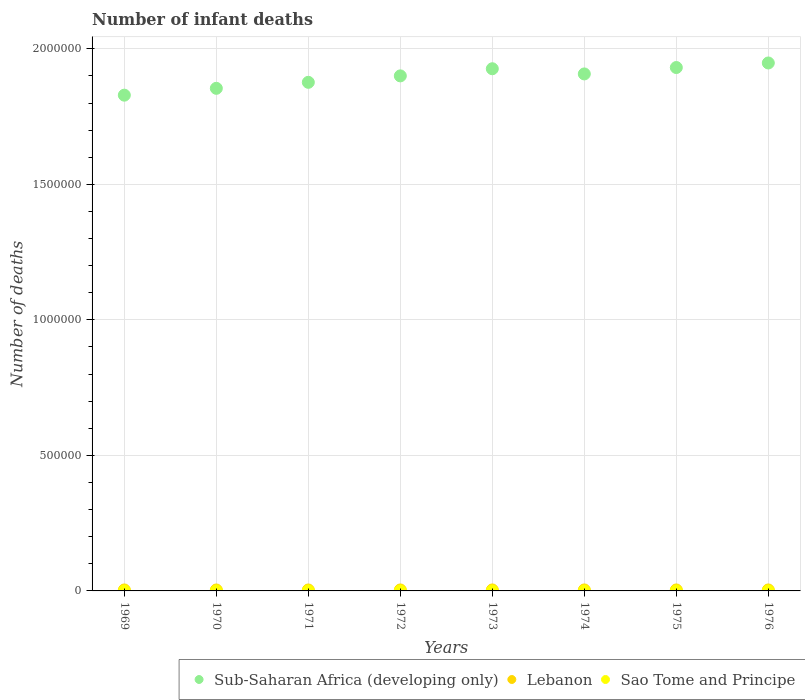What is the number of infant deaths in Lebanon in 1976?
Give a very brief answer. 3581. Across all years, what is the maximum number of infant deaths in Lebanon?
Give a very brief answer. 3623. Across all years, what is the minimum number of infant deaths in Sub-Saharan Africa (developing only)?
Keep it short and to the point. 1.83e+06. In which year was the number of infant deaths in Sao Tome and Principe maximum?
Your answer should be very brief. 1976. In which year was the number of infant deaths in Sub-Saharan Africa (developing only) minimum?
Your response must be concise. 1969. What is the total number of infant deaths in Lebanon in the graph?
Your response must be concise. 2.84e+04. What is the difference between the number of infant deaths in Lebanon in 1972 and that in 1973?
Provide a succinct answer. -52. What is the difference between the number of infant deaths in Sao Tome and Principe in 1971 and the number of infant deaths in Lebanon in 1970?
Ensure brevity in your answer.  -3272. What is the average number of infant deaths in Sao Tome and Principe per year?
Offer a very short reply. 214.12. In the year 1976, what is the difference between the number of infant deaths in Sub-Saharan Africa (developing only) and number of infant deaths in Lebanon?
Keep it short and to the point. 1.94e+06. What is the ratio of the number of infant deaths in Sub-Saharan Africa (developing only) in 1970 to that in 1972?
Ensure brevity in your answer.  0.98. Is the number of infant deaths in Lebanon in 1969 less than that in 1975?
Your answer should be compact. Yes. Is the difference between the number of infant deaths in Sub-Saharan Africa (developing only) in 1974 and 1975 greater than the difference between the number of infant deaths in Lebanon in 1974 and 1975?
Give a very brief answer. No. What is the difference between the highest and the second highest number of infant deaths in Sub-Saharan Africa (developing only)?
Give a very brief answer. 1.68e+04. In how many years, is the number of infant deaths in Lebanon greater than the average number of infant deaths in Lebanon taken over all years?
Ensure brevity in your answer.  4. Is the sum of the number of infant deaths in Lebanon in 1969 and 1974 greater than the maximum number of infant deaths in Sub-Saharan Africa (developing only) across all years?
Offer a terse response. No. Is the number of infant deaths in Sub-Saharan Africa (developing only) strictly less than the number of infant deaths in Sao Tome and Principe over the years?
Your answer should be very brief. No. What is the difference between two consecutive major ticks on the Y-axis?
Provide a short and direct response. 5.00e+05. Does the graph contain any zero values?
Ensure brevity in your answer.  No. Does the graph contain grids?
Ensure brevity in your answer.  Yes. How are the legend labels stacked?
Give a very brief answer. Horizontal. What is the title of the graph?
Ensure brevity in your answer.  Number of infant deaths. What is the label or title of the Y-axis?
Your response must be concise. Number of deaths. What is the Number of deaths of Sub-Saharan Africa (developing only) in 1969?
Provide a short and direct response. 1.83e+06. What is the Number of deaths of Lebanon in 1969?
Offer a terse response. 3530. What is the Number of deaths of Sao Tome and Principe in 1969?
Offer a very short reply. 204. What is the Number of deaths of Sub-Saharan Africa (developing only) in 1970?
Keep it short and to the point. 1.85e+06. What is the Number of deaths in Lebanon in 1970?
Provide a succinct answer. 3483. What is the Number of deaths in Sao Tome and Principe in 1970?
Your response must be concise. 209. What is the Number of deaths in Sub-Saharan Africa (developing only) in 1971?
Keep it short and to the point. 1.88e+06. What is the Number of deaths in Lebanon in 1971?
Offer a very short reply. 3481. What is the Number of deaths of Sao Tome and Principe in 1971?
Keep it short and to the point. 211. What is the Number of deaths in Sub-Saharan Africa (developing only) in 1972?
Keep it short and to the point. 1.90e+06. What is the Number of deaths of Lebanon in 1972?
Keep it short and to the point. 3532. What is the Number of deaths in Sao Tome and Principe in 1972?
Make the answer very short. 211. What is the Number of deaths in Sub-Saharan Africa (developing only) in 1973?
Give a very brief answer. 1.93e+06. What is the Number of deaths in Lebanon in 1973?
Your answer should be very brief. 3584. What is the Number of deaths of Sao Tome and Principe in 1973?
Offer a terse response. 211. What is the Number of deaths of Sub-Saharan Africa (developing only) in 1974?
Your answer should be compact. 1.91e+06. What is the Number of deaths of Lebanon in 1974?
Your answer should be very brief. 3623. What is the Number of deaths in Sao Tome and Principe in 1974?
Your answer should be compact. 213. What is the Number of deaths in Sub-Saharan Africa (developing only) in 1975?
Offer a terse response. 1.93e+06. What is the Number of deaths of Lebanon in 1975?
Ensure brevity in your answer.  3601. What is the Number of deaths in Sao Tome and Principe in 1975?
Your answer should be compact. 221. What is the Number of deaths in Sub-Saharan Africa (developing only) in 1976?
Provide a short and direct response. 1.95e+06. What is the Number of deaths of Lebanon in 1976?
Provide a succinct answer. 3581. What is the Number of deaths of Sao Tome and Principe in 1976?
Provide a short and direct response. 233. Across all years, what is the maximum Number of deaths in Sub-Saharan Africa (developing only)?
Your response must be concise. 1.95e+06. Across all years, what is the maximum Number of deaths of Lebanon?
Your answer should be compact. 3623. Across all years, what is the maximum Number of deaths in Sao Tome and Principe?
Keep it short and to the point. 233. Across all years, what is the minimum Number of deaths of Sub-Saharan Africa (developing only)?
Your answer should be very brief. 1.83e+06. Across all years, what is the minimum Number of deaths of Lebanon?
Ensure brevity in your answer.  3481. Across all years, what is the minimum Number of deaths of Sao Tome and Principe?
Make the answer very short. 204. What is the total Number of deaths of Sub-Saharan Africa (developing only) in the graph?
Ensure brevity in your answer.  1.52e+07. What is the total Number of deaths in Lebanon in the graph?
Your answer should be compact. 2.84e+04. What is the total Number of deaths of Sao Tome and Principe in the graph?
Give a very brief answer. 1713. What is the difference between the Number of deaths in Sub-Saharan Africa (developing only) in 1969 and that in 1970?
Ensure brevity in your answer.  -2.52e+04. What is the difference between the Number of deaths of Lebanon in 1969 and that in 1970?
Provide a succinct answer. 47. What is the difference between the Number of deaths in Sao Tome and Principe in 1969 and that in 1970?
Your response must be concise. -5. What is the difference between the Number of deaths in Sub-Saharan Africa (developing only) in 1969 and that in 1971?
Provide a short and direct response. -4.74e+04. What is the difference between the Number of deaths of Sub-Saharan Africa (developing only) in 1969 and that in 1972?
Offer a very short reply. -7.11e+04. What is the difference between the Number of deaths of Sao Tome and Principe in 1969 and that in 1972?
Your answer should be very brief. -7. What is the difference between the Number of deaths in Sub-Saharan Africa (developing only) in 1969 and that in 1973?
Keep it short and to the point. -9.75e+04. What is the difference between the Number of deaths of Lebanon in 1969 and that in 1973?
Provide a succinct answer. -54. What is the difference between the Number of deaths in Sub-Saharan Africa (developing only) in 1969 and that in 1974?
Your answer should be very brief. -7.83e+04. What is the difference between the Number of deaths of Lebanon in 1969 and that in 1974?
Keep it short and to the point. -93. What is the difference between the Number of deaths in Sub-Saharan Africa (developing only) in 1969 and that in 1975?
Give a very brief answer. -1.02e+05. What is the difference between the Number of deaths of Lebanon in 1969 and that in 1975?
Provide a succinct answer. -71. What is the difference between the Number of deaths of Sub-Saharan Africa (developing only) in 1969 and that in 1976?
Your answer should be very brief. -1.19e+05. What is the difference between the Number of deaths of Lebanon in 1969 and that in 1976?
Give a very brief answer. -51. What is the difference between the Number of deaths of Sao Tome and Principe in 1969 and that in 1976?
Your answer should be very brief. -29. What is the difference between the Number of deaths in Sub-Saharan Africa (developing only) in 1970 and that in 1971?
Keep it short and to the point. -2.22e+04. What is the difference between the Number of deaths in Sao Tome and Principe in 1970 and that in 1971?
Offer a very short reply. -2. What is the difference between the Number of deaths of Sub-Saharan Africa (developing only) in 1970 and that in 1972?
Make the answer very short. -4.59e+04. What is the difference between the Number of deaths of Lebanon in 1970 and that in 1972?
Your answer should be compact. -49. What is the difference between the Number of deaths of Sao Tome and Principe in 1970 and that in 1972?
Give a very brief answer. -2. What is the difference between the Number of deaths of Sub-Saharan Africa (developing only) in 1970 and that in 1973?
Make the answer very short. -7.22e+04. What is the difference between the Number of deaths of Lebanon in 1970 and that in 1973?
Offer a terse response. -101. What is the difference between the Number of deaths of Sub-Saharan Africa (developing only) in 1970 and that in 1974?
Provide a short and direct response. -5.31e+04. What is the difference between the Number of deaths in Lebanon in 1970 and that in 1974?
Ensure brevity in your answer.  -140. What is the difference between the Number of deaths in Sao Tome and Principe in 1970 and that in 1974?
Your answer should be very brief. -4. What is the difference between the Number of deaths of Sub-Saharan Africa (developing only) in 1970 and that in 1975?
Ensure brevity in your answer.  -7.67e+04. What is the difference between the Number of deaths of Lebanon in 1970 and that in 1975?
Make the answer very short. -118. What is the difference between the Number of deaths in Sao Tome and Principe in 1970 and that in 1975?
Keep it short and to the point. -12. What is the difference between the Number of deaths in Sub-Saharan Africa (developing only) in 1970 and that in 1976?
Provide a short and direct response. -9.36e+04. What is the difference between the Number of deaths in Lebanon in 1970 and that in 1976?
Ensure brevity in your answer.  -98. What is the difference between the Number of deaths of Sao Tome and Principe in 1970 and that in 1976?
Give a very brief answer. -24. What is the difference between the Number of deaths of Sub-Saharan Africa (developing only) in 1971 and that in 1972?
Keep it short and to the point. -2.38e+04. What is the difference between the Number of deaths in Lebanon in 1971 and that in 1972?
Offer a very short reply. -51. What is the difference between the Number of deaths of Sub-Saharan Africa (developing only) in 1971 and that in 1973?
Ensure brevity in your answer.  -5.01e+04. What is the difference between the Number of deaths of Lebanon in 1971 and that in 1973?
Your answer should be very brief. -103. What is the difference between the Number of deaths of Sao Tome and Principe in 1971 and that in 1973?
Your answer should be compact. 0. What is the difference between the Number of deaths in Sub-Saharan Africa (developing only) in 1971 and that in 1974?
Provide a short and direct response. -3.10e+04. What is the difference between the Number of deaths of Lebanon in 1971 and that in 1974?
Your answer should be compact. -142. What is the difference between the Number of deaths of Sao Tome and Principe in 1971 and that in 1974?
Ensure brevity in your answer.  -2. What is the difference between the Number of deaths of Sub-Saharan Africa (developing only) in 1971 and that in 1975?
Offer a very short reply. -5.46e+04. What is the difference between the Number of deaths in Lebanon in 1971 and that in 1975?
Your answer should be compact. -120. What is the difference between the Number of deaths in Sao Tome and Principe in 1971 and that in 1975?
Offer a very short reply. -10. What is the difference between the Number of deaths of Sub-Saharan Africa (developing only) in 1971 and that in 1976?
Your answer should be compact. -7.14e+04. What is the difference between the Number of deaths in Lebanon in 1971 and that in 1976?
Offer a very short reply. -100. What is the difference between the Number of deaths in Sao Tome and Principe in 1971 and that in 1976?
Your answer should be compact. -22. What is the difference between the Number of deaths of Sub-Saharan Africa (developing only) in 1972 and that in 1973?
Ensure brevity in your answer.  -2.63e+04. What is the difference between the Number of deaths in Lebanon in 1972 and that in 1973?
Provide a short and direct response. -52. What is the difference between the Number of deaths of Sub-Saharan Africa (developing only) in 1972 and that in 1974?
Provide a succinct answer. -7205. What is the difference between the Number of deaths in Lebanon in 1972 and that in 1974?
Make the answer very short. -91. What is the difference between the Number of deaths of Sao Tome and Principe in 1972 and that in 1974?
Ensure brevity in your answer.  -2. What is the difference between the Number of deaths of Sub-Saharan Africa (developing only) in 1972 and that in 1975?
Your answer should be very brief. -3.08e+04. What is the difference between the Number of deaths in Lebanon in 1972 and that in 1975?
Provide a succinct answer. -69. What is the difference between the Number of deaths in Sao Tome and Principe in 1972 and that in 1975?
Offer a terse response. -10. What is the difference between the Number of deaths of Sub-Saharan Africa (developing only) in 1972 and that in 1976?
Provide a short and direct response. -4.76e+04. What is the difference between the Number of deaths in Lebanon in 1972 and that in 1976?
Your answer should be compact. -49. What is the difference between the Number of deaths in Sub-Saharan Africa (developing only) in 1973 and that in 1974?
Offer a very short reply. 1.91e+04. What is the difference between the Number of deaths of Lebanon in 1973 and that in 1974?
Provide a succinct answer. -39. What is the difference between the Number of deaths of Sao Tome and Principe in 1973 and that in 1974?
Offer a terse response. -2. What is the difference between the Number of deaths in Sub-Saharan Africa (developing only) in 1973 and that in 1975?
Your response must be concise. -4511. What is the difference between the Number of deaths of Sub-Saharan Africa (developing only) in 1973 and that in 1976?
Provide a short and direct response. -2.13e+04. What is the difference between the Number of deaths of Lebanon in 1973 and that in 1976?
Offer a terse response. 3. What is the difference between the Number of deaths of Sao Tome and Principe in 1973 and that in 1976?
Your answer should be very brief. -22. What is the difference between the Number of deaths in Sub-Saharan Africa (developing only) in 1974 and that in 1975?
Offer a terse response. -2.36e+04. What is the difference between the Number of deaths in Lebanon in 1974 and that in 1975?
Your answer should be compact. 22. What is the difference between the Number of deaths in Sub-Saharan Africa (developing only) in 1974 and that in 1976?
Ensure brevity in your answer.  -4.04e+04. What is the difference between the Number of deaths in Sub-Saharan Africa (developing only) in 1975 and that in 1976?
Offer a terse response. -1.68e+04. What is the difference between the Number of deaths of Sao Tome and Principe in 1975 and that in 1976?
Provide a short and direct response. -12. What is the difference between the Number of deaths in Sub-Saharan Africa (developing only) in 1969 and the Number of deaths in Lebanon in 1970?
Your answer should be compact. 1.83e+06. What is the difference between the Number of deaths in Sub-Saharan Africa (developing only) in 1969 and the Number of deaths in Sao Tome and Principe in 1970?
Offer a very short reply. 1.83e+06. What is the difference between the Number of deaths of Lebanon in 1969 and the Number of deaths of Sao Tome and Principe in 1970?
Offer a very short reply. 3321. What is the difference between the Number of deaths of Sub-Saharan Africa (developing only) in 1969 and the Number of deaths of Lebanon in 1971?
Make the answer very short. 1.83e+06. What is the difference between the Number of deaths in Sub-Saharan Africa (developing only) in 1969 and the Number of deaths in Sao Tome and Principe in 1971?
Provide a succinct answer. 1.83e+06. What is the difference between the Number of deaths of Lebanon in 1969 and the Number of deaths of Sao Tome and Principe in 1971?
Provide a short and direct response. 3319. What is the difference between the Number of deaths in Sub-Saharan Africa (developing only) in 1969 and the Number of deaths in Lebanon in 1972?
Offer a terse response. 1.83e+06. What is the difference between the Number of deaths in Sub-Saharan Africa (developing only) in 1969 and the Number of deaths in Sao Tome and Principe in 1972?
Provide a succinct answer. 1.83e+06. What is the difference between the Number of deaths in Lebanon in 1969 and the Number of deaths in Sao Tome and Principe in 1972?
Your response must be concise. 3319. What is the difference between the Number of deaths in Sub-Saharan Africa (developing only) in 1969 and the Number of deaths in Lebanon in 1973?
Provide a succinct answer. 1.83e+06. What is the difference between the Number of deaths in Sub-Saharan Africa (developing only) in 1969 and the Number of deaths in Sao Tome and Principe in 1973?
Offer a terse response. 1.83e+06. What is the difference between the Number of deaths of Lebanon in 1969 and the Number of deaths of Sao Tome and Principe in 1973?
Your response must be concise. 3319. What is the difference between the Number of deaths of Sub-Saharan Africa (developing only) in 1969 and the Number of deaths of Lebanon in 1974?
Ensure brevity in your answer.  1.83e+06. What is the difference between the Number of deaths in Sub-Saharan Africa (developing only) in 1969 and the Number of deaths in Sao Tome and Principe in 1974?
Make the answer very short. 1.83e+06. What is the difference between the Number of deaths in Lebanon in 1969 and the Number of deaths in Sao Tome and Principe in 1974?
Offer a very short reply. 3317. What is the difference between the Number of deaths of Sub-Saharan Africa (developing only) in 1969 and the Number of deaths of Lebanon in 1975?
Provide a short and direct response. 1.83e+06. What is the difference between the Number of deaths in Sub-Saharan Africa (developing only) in 1969 and the Number of deaths in Sao Tome and Principe in 1975?
Your response must be concise. 1.83e+06. What is the difference between the Number of deaths in Lebanon in 1969 and the Number of deaths in Sao Tome and Principe in 1975?
Ensure brevity in your answer.  3309. What is the difference between the Number of deaths of Sub-Saharan Africa (developing only) in 1969 and the Number of deaths of Lebanon in 1976?
Provide a short and direct response. 1.83e+06. What is the difference between the Number of deaths in Sub-Saharan Africa (developing only) in 1969 and the Number of deaths in Sao Tome and Principe in 1976?
Provide a succinct answer. 1.83e+06. What is the difference between the Number of deaths of Lebanon in 1969 and the Number of deaths of Sao Tome and Principe in 1976?
Give a very brief answer. 3297. What is the difference between the Number of deaths of Sub-Saharan Africa (developing only) in 1970 and the Number of deaths of Lebanon in 1971?
Your answer should be compact. 1.85e+06. What is the difference between the Number of deaths in Sub-Saharan Africa (developing only) in 1970 and the Number of deaths in Sao Tome and Principe in 1971?
Provide a short and direct response. 1.85e+06. What is the difference between the Number of deaths in Lebanon in 1970 and the Number of deaths in Sao Tome and Principe in 1971?
Keep it short and to the point. 3272. What is the difference between the Number of deaths of Sub-Saharan Africa (developing only) in 1970 and the Number of deaths of Lebanon in 1972?
Offer a terse response. 1.85e+06. What is the difference between the Number of deaths in Sub-Saharan Africa (developing only) in 1970 and the Number of deaths in Sao Tome and Principe in 1972?
Your response must be concise. 1.85e+06. What is the difference between the Number of deaths in Lebanon in 1970 and the Number of deaths in Sao Tome and Principe in 1972?
Offer a very short reply. 3272. What is the difference between the Number of deaths in Sub-Saharan Africa (developing only) in 1970 and the Number of deaths in Lebanon in 1973?
Give a very brief answer. 1.85e+06. What is the difference between the Number of deaths in Sub-Saharan Africa (developing only) in 1970 and the Number of deaths in Sao Tome and Principe in 1973?
Provide a short and direct response. 1.85e+06. What is the difference between the Number of deaths of Lebanon in 1970 and the Number of deaths of Sao Tome and Principe in 1973?
Ensure brevity in your answer.  3272. What is the difference between the Number of deaths in Sub-Saharan Africa (developing only) in 1970 and the Number of deaths in Lebanon in 1974?
Make the answer very short. 1.85e+06. What is the difference between the Number of deaths of Sub-Saharan Africa (developing only) in 1970 and the Number of deaths of Sao Tome and Principe in 1974?
Ensure brevity in your answer.  1.85e+06. What is the difference between the Number of deaths in Lebanon in 1970 and the Number of deaths in Sao Tome and Principe in 1974?
Make the answer very short. 3270. What is the difference between the Number of deaths in Sub-Saharan Africa (developing only) in 1970 and the Number of deaths in Lebanon in 1975?
Provide a succinct answer. 1.85e+06. What is the difference between the Number of deaths of Sub-Saharan Africa (developing only) in 1970 and the Number of deaths of Sao Tome and Principe in 1975?
Keep it short and to the point. 1.85e+06. What is the difference between the Number of deaths of Lebanon in 1970 and the Number of deaths of Sao Tome and Principe in 1975?
Your answer should be compact. 3262. What is the difference between the Number of deaths in Sub-Saharan Africa (developing only) in 1970 and the Number of deaths in Lebanon in 1976?
Make the answer very short. 1.85e+06. What is the difference between the Number of deaths in Sub-Saharan Africa (developing only) in 1970 and the Number of deaths in Sao Tome and Principe in 1976?
Offer a terse response. 1.85e+06. What is the difference between the Number of deaths of Lebanon in 1970 and the Number of deaths of Sao Tome and Principe in 1976?
Provide a succinct answer. 3250. What is the difference between the Number of deaths in Sub-Saharan Africa (developing only) in 1971 and the Number of deaths in Lebanon in 1972?
Provide a short and direct response. 1.87e+06. What is the difference between the Number of deaths of Sub-Saharan Africa (developing only) in 1971 and the Number of deaths of Sao Tome and Principe in 1972?
Provide a succinct answer. 1.88e+06. What is the difference between the Number of deaths of Lebanon in 1971 and the Number of deaths of Sao Tome and Principe in 1972?
Make the answer very short. 3270. What is the difference between the Number of deaths in Sub-Saharan Africa (developing only) in 1971 and the Number of deaths in Lebanon in 1973?
Your response must be concise. 1.87e+06. What is the difference between the Number of deaths of Sub-Saharan Africa (developing only) in 1971 and the Number of deaths of Sao Tome and Principe in 1973?
Offer a very short reply. 1.88e+06. What is the difference between the Number of deaths in Lebanon in 1971 and the Number of deaths in Sao Tome and Principe in 1973?
Provide a short and direct response. 3270. What is the difference between the Number of deaths in Sub-Saharan Africa (developing only) in 1971 and the Number of deaths in Lebanon in 1974?
Provide a succinct answer. 1.87e+06. What is the difference between the Number of deaths of Sub-Saharan Africa (developing only) in 1971 and the Number of deaths of Sao Tome and Principe in 1974?
Offer a terse response. 1.88e+06. What is the difference between the Number of deaths in Lebanon in 1971 and the Number of deaths in Sao Tome and Principe in 1974?
Your answer should be compact. 3268. What is the difference between the Number of deaths of Sub-Saharan Africa (developing only) in 1971 and the Number of deaths of Lebanon in 1975?
Ensure brevity in your answer.  1.87e+06. What is the difference between the Number of deaths in Sub-Saharan Africa (developing only) in 1971 and the Number of deaths in Sao Tome and Principe in 1975?
Offer a very short reply. 1.88e+06. What is the difference between the Number of deaths in Lebanon in 1971 and the Number of deaths in Sao Tome and Principe in 1975?
Ensure brevity in your answer.  3260. What is the difference between the Number of deaths of Sub-Saharan Africa (developing only) in 1971 and the Number of deaths of Lebanon in 1976?
Your answer should be very brief. 1.87e+06. What is the difference between the Number of deaths in Sub-Saharan Africa (developing only) in 1971 and the Number of deaths in Sao Tome and Principe in 1976?
Provide a short and direct response. 1.88e+06. What is the difference between the Number of deaths in Lebanon in 1971 and the Number of deaths in Sao Tome and Principe in 1976?
Provide a succinct answer. 3248. What is the difference between the Number of deaths of Sub-Saharan Africa (developing only) in 1972 and the Number of deaths of Lebanon in 1973?
Keep it short and to the point. 1.90e+06. What is the difference between the Number of deaths of Sub-Saharan Africa (developing only) in 1972 and the Number of deaths of Sao Tome and Principe in 1973?
Offer a terse response. 1.90e+06. What is the difference between the Number of deaths in Lebanon in 1972 and the Number of deaths in Sao Tome and Principe in 1973?
Keep it short and to the point. 3321. What is the difference between the Number of deaths of Sub-Saharan Africa (developing only) in 1972 and the Number of deaths of Lebanon in 1974?
Offer a terse response. 1.90e+06. What is the difference between the Number of deaths in Sub-Saharan Africa (developing only) in 1972 and the Number of deaths in Sao Tome and Principe in 1974?
Keep it short and to the point. 1.90e+06. What is the difference between the Number of deaths of Lebanon in 1972 and the Number of deaths of Sao Tome and Principe in 1974?
Provide a succinct answer. 3319. What is the difference between the Number of deaths of Sub-Saharan Africa (developing only) in 1972 and the Number of deaths of Lebanon in 1975?
Make the answer very short. 1.90e+06. What is the difference between the Number of deaths in Sub-Saharan Africa (developing only) in 1972 and the Number of deaths in Sao Tome and Principe in 1975?
Offer a very short reply. 1.90e+06. What is the difference between the Number of deaths in Lebanon in 1972 and the Number of deaths in Sao Tome and Principe in 1975?
Offer a terse response. 3311. What is the difference between the Number of deaths of Sub-Saharan Africa (developing only) in 1972 and the Number of deaths of Lebanon in 1976?
Your answer should be compact. 1.90e+06. What is the difference between the Number of deaths of Sub-Saharan Africa (developing only) in 1972 and the Number of deaths of Sao Tome and Principe in 1976?
Ensure brevity in your answer.  1.90e+06. What is the difference between the Number of deaths in Lebanon in 1972 and the Number of deaths in Sao Tome and Principe in 1976?
Your answer should be very brief. 3299. What is the difference between the Number of deaths in Sub-Saharan Africa (developing only) in 1973 and the Number of deaths in Lebanon in 1974?
Give a very brief answer. 1.92e+06. What is the difference between the Number of deaths of Sub-Saharan Africa (developing only) in 1973 and the Number of deaths of Sao Tome and Principe in 1974?
Make the answer very short. 1.93e+06. What is the difference between the Number of deaths in Lebanon in 1973 and the Number of deaths in Sao Tome and Principe in 1974?
Make the answer very short. 3371. What is the difference between the Number of deaths of Sub-Saharan Africa (developing only) in 1973 and the Number of deaths of Lebanon in 1975?
Your answer should be very brief. 1.92e+06. What is the difference between the Number of deaths in Sub-Saharan Africa (developing only) in 1973 and the Number of deaths in Sao Tome and Principe in 1975?
Your response must be concise. 1.93e+06. What is the difference between the Number of deaths in Lebanon in 1973 and the Number of deaths in Sao Tome and Principe in 1975?
Ensure brevity in your answer.  3363. What is the difference between the Number of deaths in Sub-Saharan Africa (developing only) in 1973 and the Number of deaths in Lebanon in 1976?
Offer a very short reply. 1.92e+06. What is the difference between the Number of deaths in Sub-Saharan Africa (developing only) in 1973 and the Number of deaths in Sao Tome and Principe in 1976?
Your answer should be compact. 1.93e+06. What is the difference between the Number of deaths in Lebanon in 1973 and the Number of deaths in Sao Tome and Principe in 1976?
Offer a terse response. 3351. What is the difference between the Number of deaths of Sub-Saharan Africa (developing only) in 1974 and the Number of deaths of Lebanon in 1975?
Provide a succinct answer. 1.90e+06. What is the difference between the Number of deaths of Sub-Saharan Africa (developing only) in 1974 and the Number of deaths of Sao Tome and Principe in 1975?
Make the answer very short. 1.91e+06. What is the difference between the Number of deaths of Lebanon in 1974 and the Number of deaths of Sao Tome and Principe in 1975?
Ensure brevity in your answer.  3402. What is the difference between the Number of deaths of Sub-Saharan Africa (developing only) in 1974 and the Number of deaths of Lebanon in 1976?
Give a very brief answer. 1.90e+06. What is the difference between the Number of deaths of Sub-Saharan Africa (developing only) in 1974 and the Number of deaths of Sao Tome and Principe in 1976?
Offer a terse response. 1.91e+06. What is the difference between the Number of deaths of Lebanon in 1974 and the Number of deaths of Sao Tome and Principe in 1976?
Your answer should be compact. 3390. What is the difference between the Number of deaths in Sub-Saharan Africa (developing only) in 1975 and the Number of deaths in Lebanon in 1976?
Provide a short and direct response. 1.93e+06. What is the difference between the Number of deaths of Sub-Saharan Africa (developing only) in 1975 and the Number of deaths of Sao Tome and Principe in 1976?
Your answer should be very brief. 1.93e+06. What is the difference between the Number of deaths of Lebanon in 1975 and the Number of deaths of Sao Tome and Principe in 1976?
Give a very brief answer. 3368. What is the average Number of deaths in Sub-Saharan Africa (developing only) per year?
Keep it short and to the point. 1.90e+06. What is the average Number of deaths of Lebanon per year?
Offer a terse response. 3551.88. What is the average Number of deaths of Sao Tome and Principe per year?
Ensure brevity in your answer.  214.12. In the year 1969, what is the difference between the Number of deaths in Sub-Saharan Africa (developing only) and Number of deaths in Lebanon?
Provide a short and direct response. 1.83e+06. In the year 1969, what is the difference between the Number of deaths in Sub-Saharan Africa (developing only) and Number of deaths in Sao Tome and Principe?
Keep it short and to the point. 1.83e+06. In the year 1969, what is the difference between the Number of deaths of Lebanon and Number of deaths of Sao Tome and Principe?
Your answer should be very brief. 3326. In the year 1970, what is the difference between the Number of deaths of Sub-Saharan Africa (developing only) and Number of deaths of Lebanon?
Your response must be concise. 1.85e+06. In the year 1970, what is the difference between the Number of deaths in Sub-Saharan Africa (developing only) and Number of deaths in Sao Tome and Principe?
Provide a succinct answer. 1.85e+06. In the year 1970, what is the difference between the Number of deaths in Lebanon and Number of deaths in Sao Tome and Principe?
Make the answer very short. 3274. In the year 1971, what is the difference between the Number of deaths in Sub-Saharan Africa (developing only) and Number of deaths in Lebanon?
Provide a succinct answer. 1.87e+06. In the year 1971, what is the difference between the Number of deaths of Sub-Saharan Africa (developing only) and Number of deaths of Sao Tome and Principe?
Your response must be concise. 1.88e+06. In the year 1971, what is the difference between the Number of deaths in Lebanon and Number of deaths in Sao Tome and Principe?
Ensure brevity in your answer.  3270. In the year 1972, what is the difference between the Number of deaths in Sub-Saharan Africa (developing only) and Number of deaths in Lebanon?
Your answer should be very brief. 1.90e+06. In the year 1972, what is the difference between the Number of deaths in Sub-Saharan Africa (developing only) and Number of deaths in Sao Tome and Principe?
Your response must be concise. 1.90e+06. In the year 1972, what is the difference between the Number of deaths of Lebanon and Number of deaths of Sao Tome and Principe?
Provide a short and direct response. 3321. In the year 1973, what is the difference between the Number of deaths in Sub-Saharan Africa (developing only) and Number of deaths in Lebanon?
Ensure brevity in your answer.  1.92e+06. In the year 1973, what is the difference between the Number of deaths of Sub-Saharan Africa (developing only) and Number of deaths of Sao Tome and Principe?
Your answer should be compact. 1.93e+06. In the year 1973, what is the difference between the Number of deaths in Lebanon and Number of deaths in Sao Tome and Principe?
Keep it short and to the point. 3373. In the year 1974, what is the difference between the Number of deaths of Sub-Saharan Africa (developing only) and Number of deaths of Lebanon?
Your answer should be compact. 1.90e+06. In the year 1974, what is the difference between the Number of deaths in Sub-Saharan Africa (developing only) and Number of deaths in Sao Tome and Principe?
Offer a very short reply. 1.91e+06. In the year 1974, what is the difference between the Number of deaths of Lebanon and Number of deaths of Sao Tome and Principe?
Offer a very short reply. 3410. In the year 1975, what is the difference between the Number of deaths of Sub-Saharan Africa (developing only) and Number of deaths of Lebanon?
Offer a very short reply. 1.93e+06. In the year 1975, what is the difference between the Number of deaths of Sub-Saharan Africa (developing only) and Number of deaths of Sao Tome and Principe?
Keep it short and to the point. 1.93e+06. In the year 1975, what is the difference between the Number of deaths of Lebanon and Number of deaths of Sao Tome and Principe?
Your response must be concise. 3380. In the year 1976, what is the difference between the Number of deaths of Sub-Saharan Africa (developing only) and Number of deaths of Lebanon?
Ensure brevity in your answer.  1.94e+06. In the year 1976, what is the difference between the Number of deaths in Sub-Saharan Africa (developing only) and Number of deaths in Sao Tome and Principe?
Make the answer very short. 1.95e+06. In the year 1976, what is the difference between the Number of deaths of Lebanon and Number of deaths of Sao Tome and Principe?
Your answer should be very brief. 3348. What is the ratio of the Number of deaths of Sub-Saharan Africa (developing only) in 1969 to that in 1970?
Your answer should be very brief. 0.99. What is the ratio of the Number of deaths in Lebanon in 1969 to that in 1970?
Offer a very short reply. 1.01. What is the ratio of the Number of deaths of Sao Tome and Principe in 1969 to that in 1970?
Give a very brief answer. 0.98. What is the ratio of the Number of deaths of Sub-Saharan Africa (developing only) in 1969 to that in 1971?
Keep it short and to the point. 0.97. What is the ratio of the Number of deaths in Lebanon in 1969 to that in 1971?
Make the answer very short. 1.01. What is the ratio of the Number of deaths in Sao Tome and Principe in 1969 to that in 1971?
Make the answer very short. 0.97. What is the ratio of the Number of deaths in Sub-Saharan Africa (developing only) in 1969 to that in 1972?
Ensure brevity in your answer.  0.96. What is the ratio of the Number of deaths of Sao Tome and Principe in 1969 to that in 1972?
Give a very brief answer. 0.97. What is the ratio of the Number of deaths of Sub-Saharan Africa (developing only) in 1969 to that in 1973?
Provide a succinct answer. 0.95. What is the ratio of the Number of deaths of Lebanon in 1969 to that in 1973?
Your answer should be compact. 0.98. What is the ratio of the Number of deaths in Sao Tome and Principe in 1969 to that in 1973?
Your answer should be very brief. 0.97. What is the ratio of the Number of deaths in Sub-Saharan Africa (developing only) in 1969 to that in 1974?
Provide a succinct answer. 0.96. What is the ratio of the Number of deaths in Lebanon in 1969 to that in 1974?
Give a very brief answer. 0.97. What is the ratio of the Number of deaths of Sao Tome and Principe in 1969 to that in 1974?
Give a very brief answer. 0.96. What is the ratio of the Number of deaths in Sub-Saharan Africa (developing only) in 1969 to that in 1975?
Offer a terse response. 0.95. What is the ratio of the Number of deaths in Lebanon in 1969 to that in 1975?
Offer a terse response. 0.98. What is the ratio of the Number of deaths of Sub-Saharan Africa (developing only) in 1969 to that in 1976?
Provide a succinct answer. 0.94. What is the ratio of the Number of deaths of Lebanon in 1969 to that in 1976?
Provide a succinct answer. 0.99. What is the ratio of the Number of deaths of Sao Tome and Principe in 1969 to that in 1976?
Offer a terse response. 0.88. What is the ratio of the Number of deaths of Sub-Saharan Africa (developing only) in 1970 to that in 1971?
Offer a terse response. 0.99. What is the ratio of the Number of deaths of Lebanon in 1970 to that in 1971?
Ensure brevity in your answer.  1. What is the ratio of the Number of deaths of Sao Tome and Principe in 1970 to that in 1971?
Give a very brief answer. 0.99. What is the ratio of the Number of deaths in Sub-Saharan Africa (developing only) in 1970 to that in 1972?
Provide a short and direct response. 0.98. What is the ratio of the Number of deaths in Lebanon in 1970 to that in 1972?
Your response must be concise. 0.99. What is the ratio of the Number of deaths in Sao Tome and Principe in 1970 to that in 1972?
Offer a terse response. 0.99. What is the ratio of the Number of deaths of Sub-Saharan Africa (developing only) in 1970 to that in 1973?
Your answer should be compact. 0.96. What is the ratio of the Number of deaths of Lebanon in 1970 to that in 1973?
Your answer should be very brief. 0.97. What is the ratio of the Number of deaths in Sao Tome and Principe in 1970 to that in 1973?
Offer a very short reply. 0.99. What is the ratio of the Number of deaths in Sub-Saharan Africa (developing only) in 1970 to that in 1974?
Ensure brevity in your answer.  0.97. What is the ratio of the Number of deaths in Lebanon in 1970 to that in 1974?
Your answer should be compact. 0.96. What is the ratio of the Number of deaths in Sao Tome and Principe in 1970 to that in 1974?
Provide a short and direct response. 0.98. What is the ratio of the Number of deaths of Sub-Saharan Africa (developing only) in 1970 to that in 1975?
Ensure brevity in your answer.  0.96. What is the ratio of the Number of deaths in Lebanon in 1970 to that in 1975?
Give a very brief answer. 0.97. What is the ratio of the Number of deaths in Sao Tome and Principe in 1970 to that in 1975?
Provide a succinct answer. 0.95. What is the ratio of the Number of deaths in Lebanon in 1970 to that in 1976?
Ensure brevity in your answer.  0.97. What is the ratio of the Number of deaths in Sao Tome and Principe in 1970 to that in 1976?
Your answer should be compact. 0.9. What is the ratio of the Number of deaths in Sub-Saharan Africa (developing only) in 1971 to that in 1972?
Ensure brevity in your answer.  0.99. What is the ratio of the Number of deaths of Lebanon in 1971 to that in 1972?
Give a very brief answer. 0.99. What is the ratio of the Number of deaths of Sao Tome and Principe in 1971 to that in 1972?
Provide a short and direct response. 1. What is the ratio of the Number of deaths of Lebanon in 1971 to that in 1973?
Make the answer very short. 0.97. What is the ratio of the Number of deaths of Sao Tome and Principe in 1971 to that in 1973?
Offer a terse response. 1. What is the ratio of the Number of deaths in Sub-Saharan Africa (developing only) in 1971 to that in 1974?
Your answer should be very brief. 0.98. What is the ratio of the Number of deaths of Lebanon in 1971 to that in 1974?
Provide a succinct answer. 0.96. What is the ratio of the Number of deaths of Sao Tome and Principe in 1971 to that in 1974?
Keep it short and to the point. 0.99. What is the ratio of the Number of deaths in Sub-Saharan Africa (developing only) in 1971 to that in 1975?
Provide a succinct answer. 0.97. What is the ratio of the Number of deaths in Lebanon in 1971 to that in 1975?
Your response must be concise. 0.97. What is the ratio of the Number of deaths of Sao Tome and Principe in 1971 to that in 1975?
Ensure brevity in your answer.  0.95. What is the ratio of the Number of deaths in Sub-Saharan Africa (developing only) in 1971 to that in 1976?
Offer a terse response. 0.96. What is the ratio of the Number of deaths of Lebanon in 1971 to that in 1976?
Offer a terse response. 0.97. What is the ratio of the Number of deaths in Sao Tome and Principe in 1971 to that in 1976?
Ensure brevity in your answer.  0.91. What is the ratio of the Number of deaths in Sub-Saharan Africa (developing only) in 1972 to that in 1973?
Your answer should be very brief. 0.99. What is the ratio of the Number of deaths in Lebanon in 1972 to that in 1973?
Your response must be concise. 0.99. What is the ratio of the Number of deaths in Sub-Saharan Africa (developing only) in 1972 to that in 1974?
Keep it short and to the point. 1. What is the ratio of the Number of deaths of Lebanon in 1972 to that in 1974?
Your answer should be compact. 0.97. What is the ratio of the Number of deaths in Sao Tome and Principe in 1972 to that in 1974?
Offer a very short reply. 0.99. What is the ratio of the Number of deaths in Lebanon in 1972 to that in 1975?
Your answer should be very brief. 0.98. What is the ratio of the Number of deaths of Sao Tome and Principe in 1972 to that in 1975?
Your answer should be compact. 0.95. What is the ratio of the Number of deaths of Sub-Saharan Africa (developing only) in 1972 to that in 1976?
Provide a succinct answer. 0.98. What is the ratio of the Number of deaths of Lebanon in 1972 to that in 1976?
Make the answer very short. 0.99. What is the ratio of the Number of deaths in Sao Tome and Principe in 1972 to that in 1976?
Your response must be concise. 0.91. What is the ratio of the Number of deaths of Sao Tome and Principe in 1973 to that in 1974?
Make the answer very short. 0.99. What is the ratio of the Number of deaths of Lebanon in 1973 to that in 1975?
Give a very brief answer. 1. What is the ratio of the Number of deaths in Sao Tome and Principe in 1973 to that in 1975?
Your response must be concise. 0.95. What is the ratio of the Number of deaths of Sub-Saharan Africa (developing only) in 1973 to that in 1976?
Keep it short and to the point. 0.99. What is the ratio of the Number of deaths in Lebanon in 1973 to that in 1976?
Offer a very short reply. 1. What is the ratio of the Number of deaths in Sao Tome and Principe in 1973 to that in 1976?
Your response must be concise. 0.91. What is the ratio of the Number of deaths in Sao Tome and Principe in 1974 to that in 1975?
Offer a very short reply. 0.96. What is the ratio of the Number of deaths in Sub-Saharan Africa (developing only) in 1974 to that in 1976?
Give a very brief answer. 0.98. What is the ratio of the Number of deaths of Lebanon in 1974 to that in 1976?
Your answer should be very brief. 1.01. What is the ratio of the Number of deaths in Sao Tome and Principe in 1974 to that in 1976?
Offer a terse response. 0.91. What is the ratio of the Number of deaths of Sub-Saharan Africa (developing only) in 1975 to that in 1976?
Your answer should be very brief. 0.99. What is the ratio of the Number of deaths in Lebanon in 1975 to that in 1976?
Your answer should be very brief. 1.01. What is the ratio of the Number of deaths of Sao Tome and Principe in 1975 to that in 1976?
Give a very brief answer. 0.95. What is the difference between the highest and the second highest Number of deaths in Sub-Saharan Africa (developing only)?
Ensure brevity in your answer.  1.68e+04. What is the difference between the highest and the second highest Number of deaths of Sao Tome and Principe?
Give a very brief answer. 12. What is the difference between the highest and the lowest Number of deaths in Sub-Saharan Africa (developing only)?
Keep it short and to the point. 1.19e+05. What is the difference between the highest and the lowest Number of deaths of Lebanon?
Your answer should be compact. 142. 